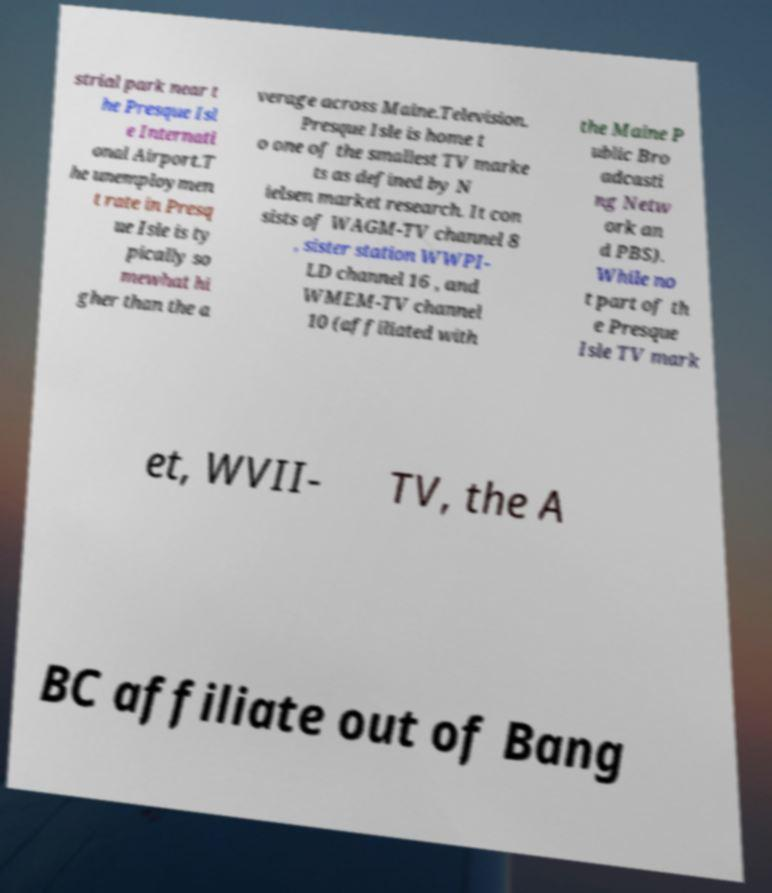Please identify and transcribe the text found in this image. strial park near t he Presque Isl e Internati onal Airport.T he unemploymen t rate in Presq ue Isle is ty pically so mewhat hi gher than the a verage across Maine.Television. Presque Isle is home t o one of the smallest TV marke ts as defined by N ielsen market research. It con sists of WAGM-TV channel 8 , sister station WWPI- LD channel 16 , and WMEM-TV channel 10 (affiliated with the Maine P ublic Bro adcasti ng Netw ork an d PBS). While no t part of th e Presque Isle TV mark et, WVII- TV, the A BC affiliate out of Bang 